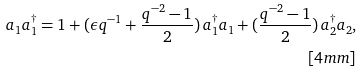<formula> <loc_0><loc_0><loc_500><loc_500>a _ { 1 } a _ { 1 } ^ { \dagger } = 1 + ( \epsilon q ^ { - 1 } + \frac { q ^ { - 2 } - 1 } { 2 } ) \, a _ { 1 } ^ { \dagger } a _ { 1 } + ( \frac { q ^ { - 2 } - 1 } { 2 } ) \, a _ { 2 } ^ { \dagger } a _ { 2 } , \\ [ 4 m m ]</formula> 